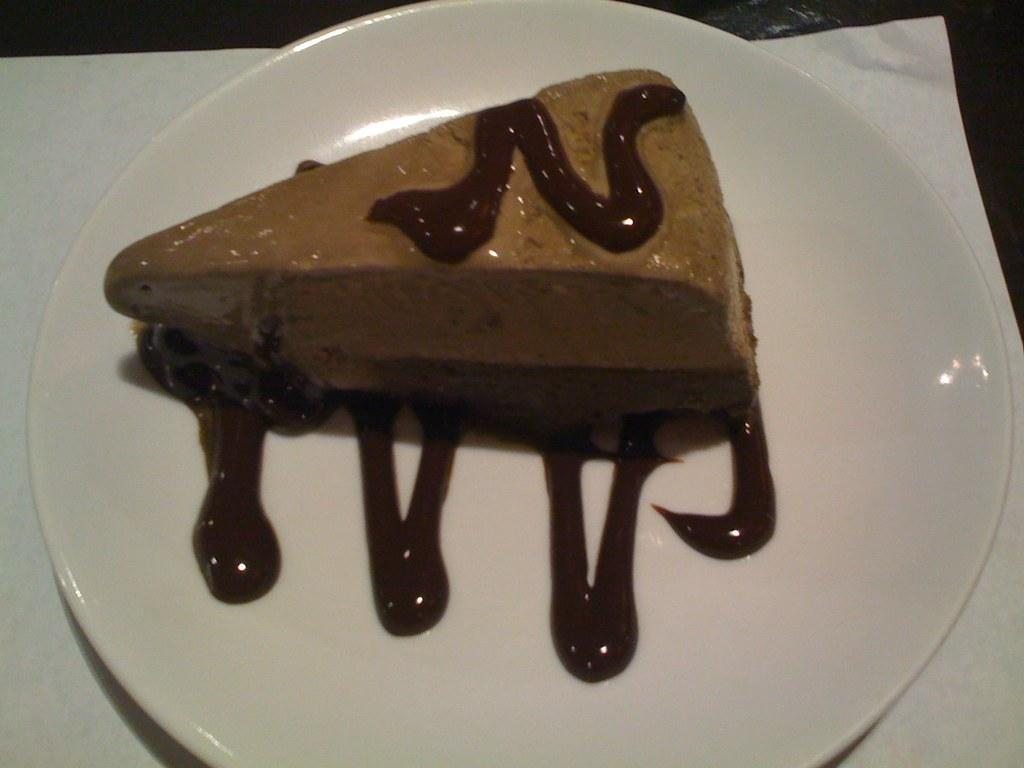What is on the plate in the image? There is a food item on a plate in the image. What color is the plate? The plate is white. What is the plate placed on? The plate is on a white paper. What word is written on the plate in the image? There is no word written on the plate in the image. Is there a club visible in the image? There is no club present in the image. 